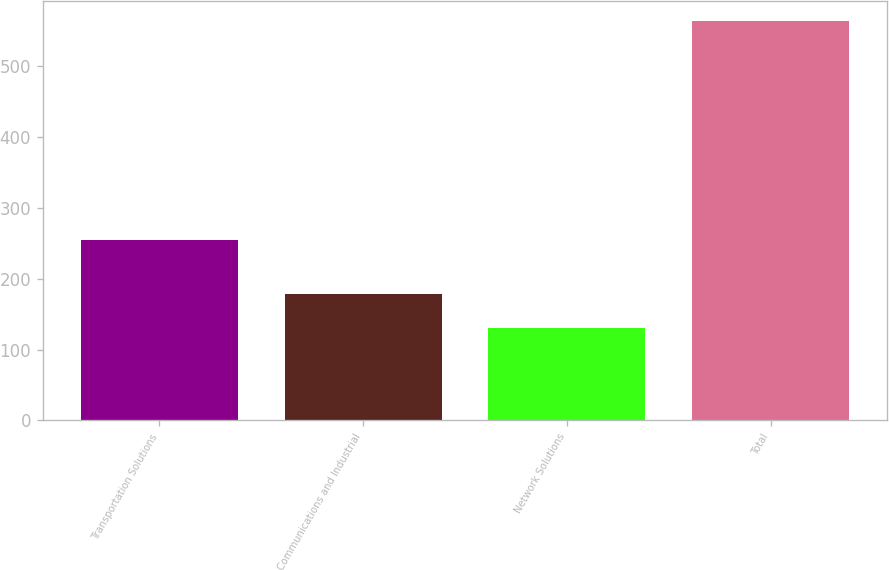Convert chart. <chart><loc_0><loc_0><loc_500><loc_500><bar_chart><fcel>Transportation Solutions<fcel>Communications and Industrial<fcel>Network Solutions<fcel>Total<nl><fcel>255<fcel>178<fcel>131<fcel>564<nl></chart> 